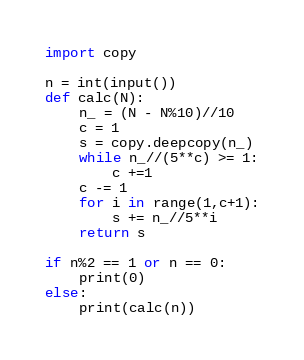<code> <loc_0><loc_0><loc_500><loc_500><_Python_>import copy

n = int(input())
def calc(N):
    n_ = (N - N%10)//10
    c = 1
    s = copy.deepcopy(n_)
    while n_//(5**c) >= 1:
        c +=1
    c -= 1
    for i in range(1,c+1):
        s += n_//5**i
    return s

if n%2 == 1 or n == 0:
    print(0)
else:
    print(calc(n))





</code> 